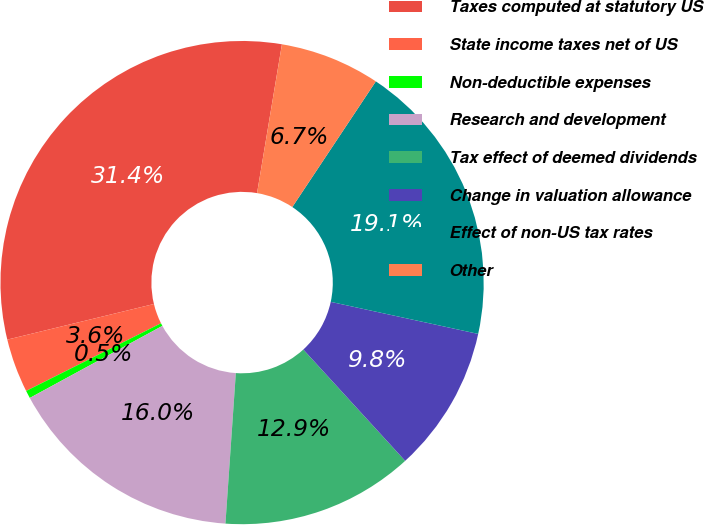Convert chart. <chart><loc_0><loc_0><loc_500><loc_500><pie_chart><fcel>Taxes computed at statutory US<fcel>State income taxes net of US<fcel>Non-deductible expenses<fcel>Research and development<fcel>Tax effect of deemed dividends<fcel>Change in valuation allowance<fcel>Effect of non-US tax rates<fcel>Other<nl><fcel>31.43%<fcel>3.61%<fcel>0.52%<fcel>15.98%<fcel>12.89%<fcel>9.8%<fcel>19.07%<fcel>6.7%<nl></chart> 